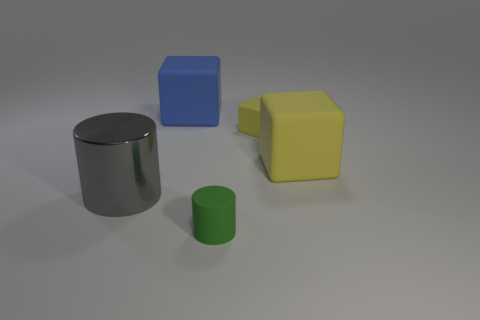How many yellow things are the same size as the green object?
Provide a succinct answer. 1. What is the material of the tiny yellow object that is the same shape as the large yellow thing?
Offer a terse response. Rubber. Does the large yellow object have the same shape as the large metal thing?
Your answer should be compact. No. What number of yellow rubber objects are to the right of the shiny object?
Make the answer very short. 2. What shape is the yellow thing that is left of the large matte thing that is right of the big blue rubber object?
Make the answer very short. Cube. There is a blue object that is the same material as the green cylinder; what is its shape?
Offer a terse response. Cube. Do the thing that is to the right of the small block and the object to the left of the blue rubber block have the same size?
Make the answer very short. Yes. There is a big thing right of the large blue rubber object; what shape is it?
Your response must be concise. Cube. What is the color of the tiny cylinder?
Your answer should be very brief. Green. Does the green object have the same size as the blue thing that is to the left of the large yellow thing?
Provide a succinct answer. No. 